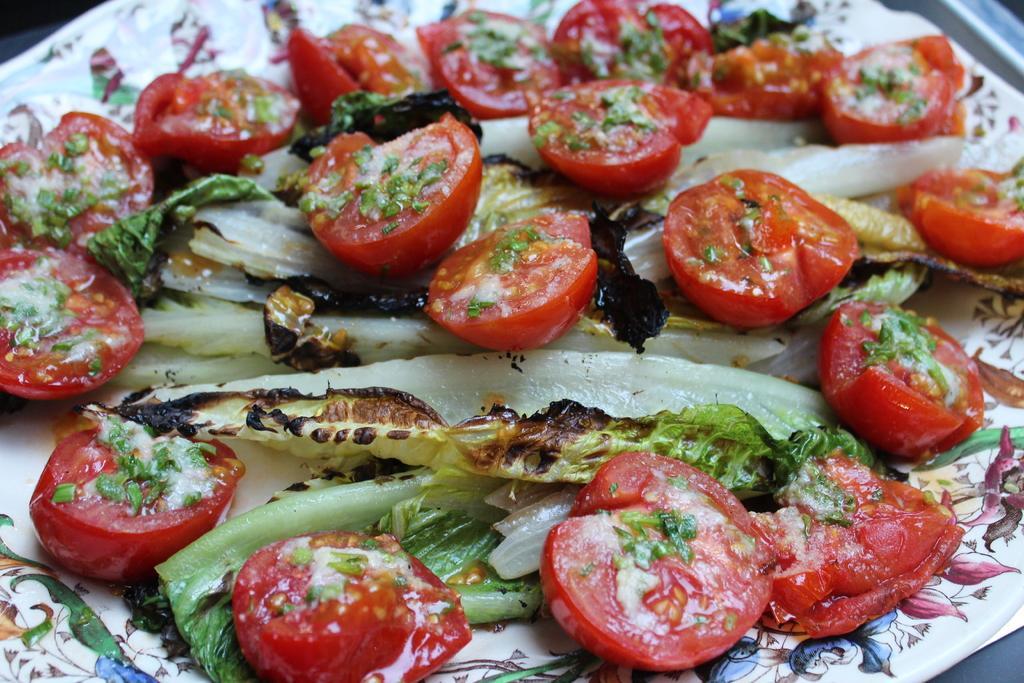In one or two sentences, can you explain what this image depicts? In this picture we see a plate of salad made of tomatoes, cabbage and other vegetables. 